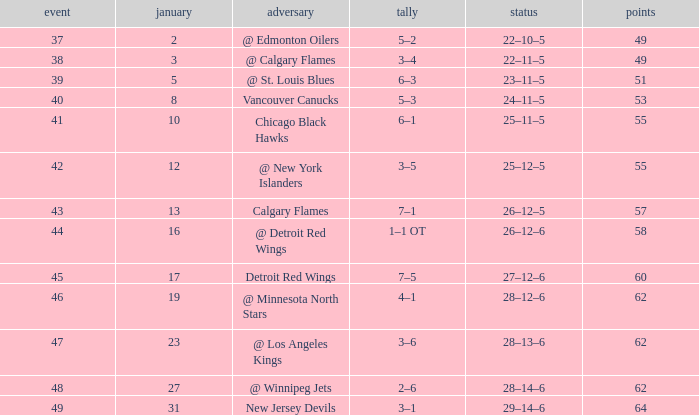How many Games have a Score of 2–6, and Points larger than 62? 0.0. 